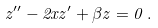Convert formula to latex. <formula><loc_0><loc_0><loc_500><loc_500>z ^ { \prime \prime } - 2 x z ^ { \prime } + \beta z = 0 \, .</formula> 